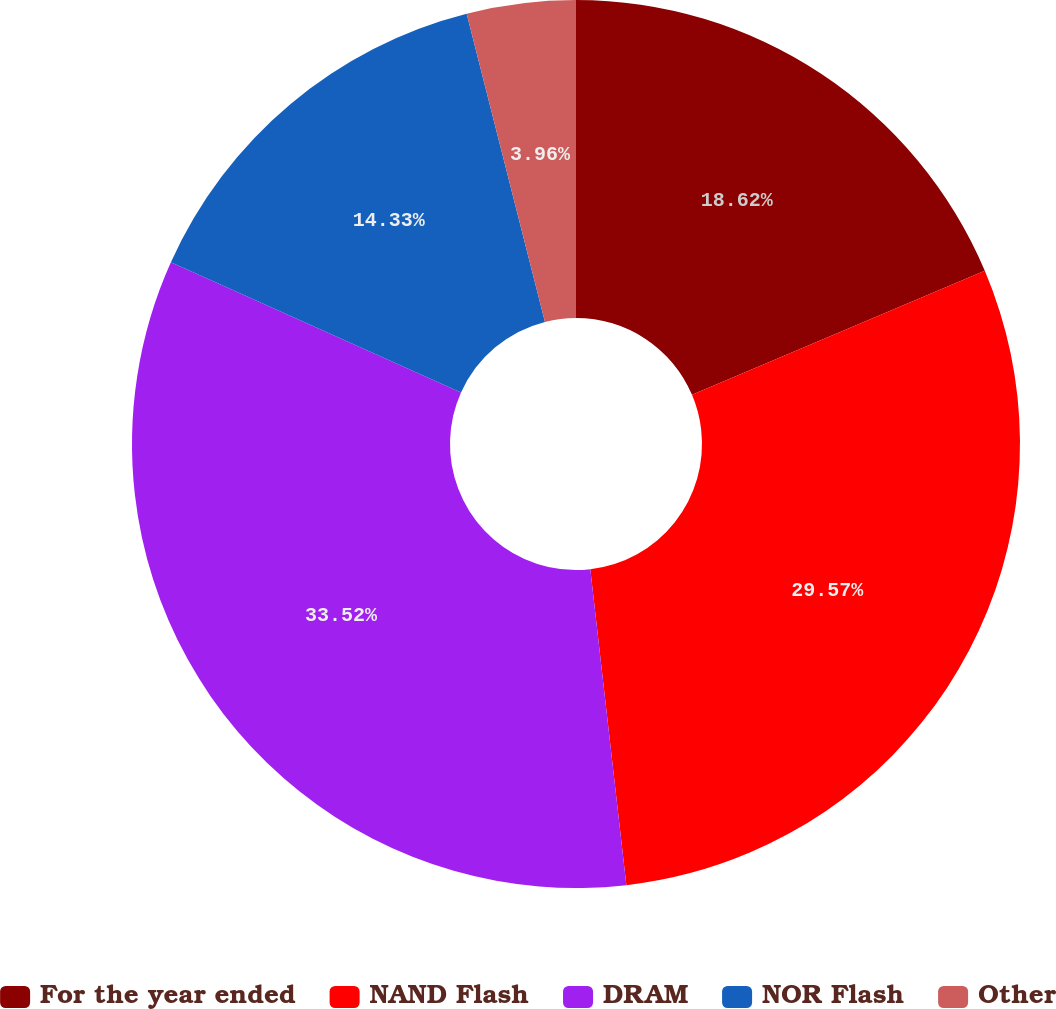Convert chart. <chart><loc_0><loc_0><loc_500><loc_500><pie_chart><fcel>For the year ended<fcel>NAND Flash<fcel>DRAM<fcel>NOR Flash<fcel>Other<nl><fcel>18.62%<fcel>29.57%<fcel>33.52%<fcel>14.33%<fcel>3.96%<nl></chart> 